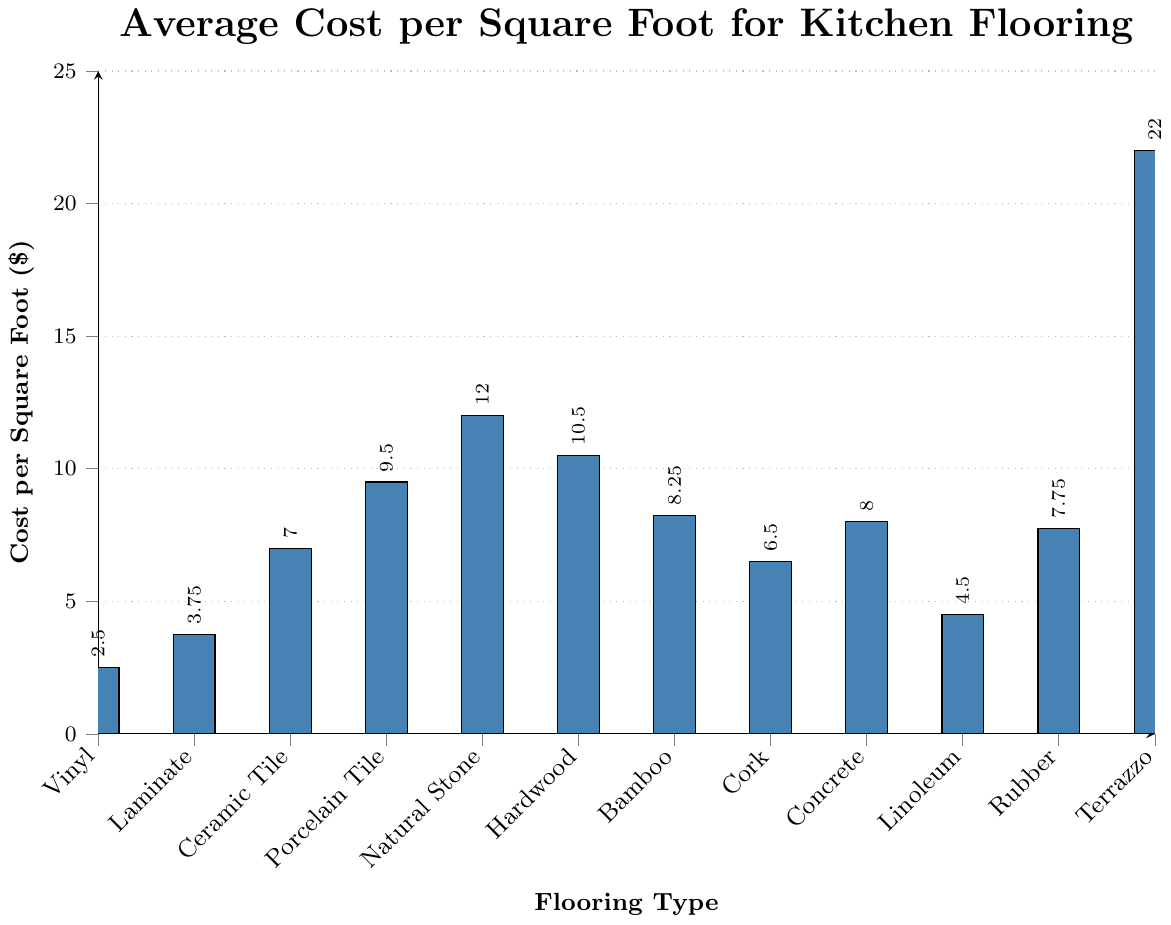What is the average cost per square foot of Linoleum and Vinyl? The cost per square foot of Linoleum is $4.50 and Vinyl is $2.50. To find the average: ($4.50 + $2.50) / 2 = $7.00 / 2 = $3.50
Answer: $3.50 Which flooring type has the highest average cost per square foot? By visually comparing the heights of the bars, Terrazzo has the highest bar, indicating the highest cost per square foot at $22.00
Answer: Terrazzo How much more expensive per square foot is Porcelain Tile compared to Laminate? Porcelain Tile costs $9.50 per square foot, and Laminate costs $3.75 per square foot. The difference is $9.50 - $3.75 = $5.75
Answer: $5.75 What is the median cost per square foot of all flooring types? First, list all costs in ascending order: $2.50, $3.75, $4.50, $6.50, $7.00, $7.75, $8.00, $8.25, $9.50, $10.50, $12.00, $22.00. Since there are 12 values, the median is the average of the 6th and 7th values, which are $7.75 and $8.00. So, the median is ($7.75 + $8.00) / 2 = $15.75 / 2 = $7.875
Answer: $7.875 Is hardwood more expensive than concrete? By visually comparing the heights of the bars, Hardwood costs $10.50 per square foot and Concrete costs $8.00 per square foot. Therefore, Hardwood is more expensive than Concrete
Answer: Yes If I have a budget of $50, which flooring types can I afford to cover at least 5 square feet? To find this, divide $50 by the cost per square foot for each type and check which ones cover at least 5 square feet. Viable options: Vinyl ($50/$2.50=20 sq ft), Laminate ($50/$3.75=13.33 sq ft), Linoleum ($50/$4.50=11.11 sq ft), Cork ($50/$6.50=7.69 sq ft), Ceramic Tile ($50/$7.00=7.14 sq ft). Hence, the types are Vinyl, Laminate, Linoleum, Cork, and Ceramic Tile
Answer: Vinyl, Laminate, Linoleum, Cork, Ceramic Tile Which is cheaper on average: Bamboo or Rubber? Bamboo costs $8.25 per square foot, and Rubber costs $7.75 per square foot. Therefore, Rubber is cheaper than Bamboo
Answer: Rubber How much would it cost to cover a 100 square foot kitchen with Ceramic Tile? Multiply the cost per square foot of Ceramic Tile by 100. So, $7.00 per square foot * 100 square feet = $700
Answer: $700 